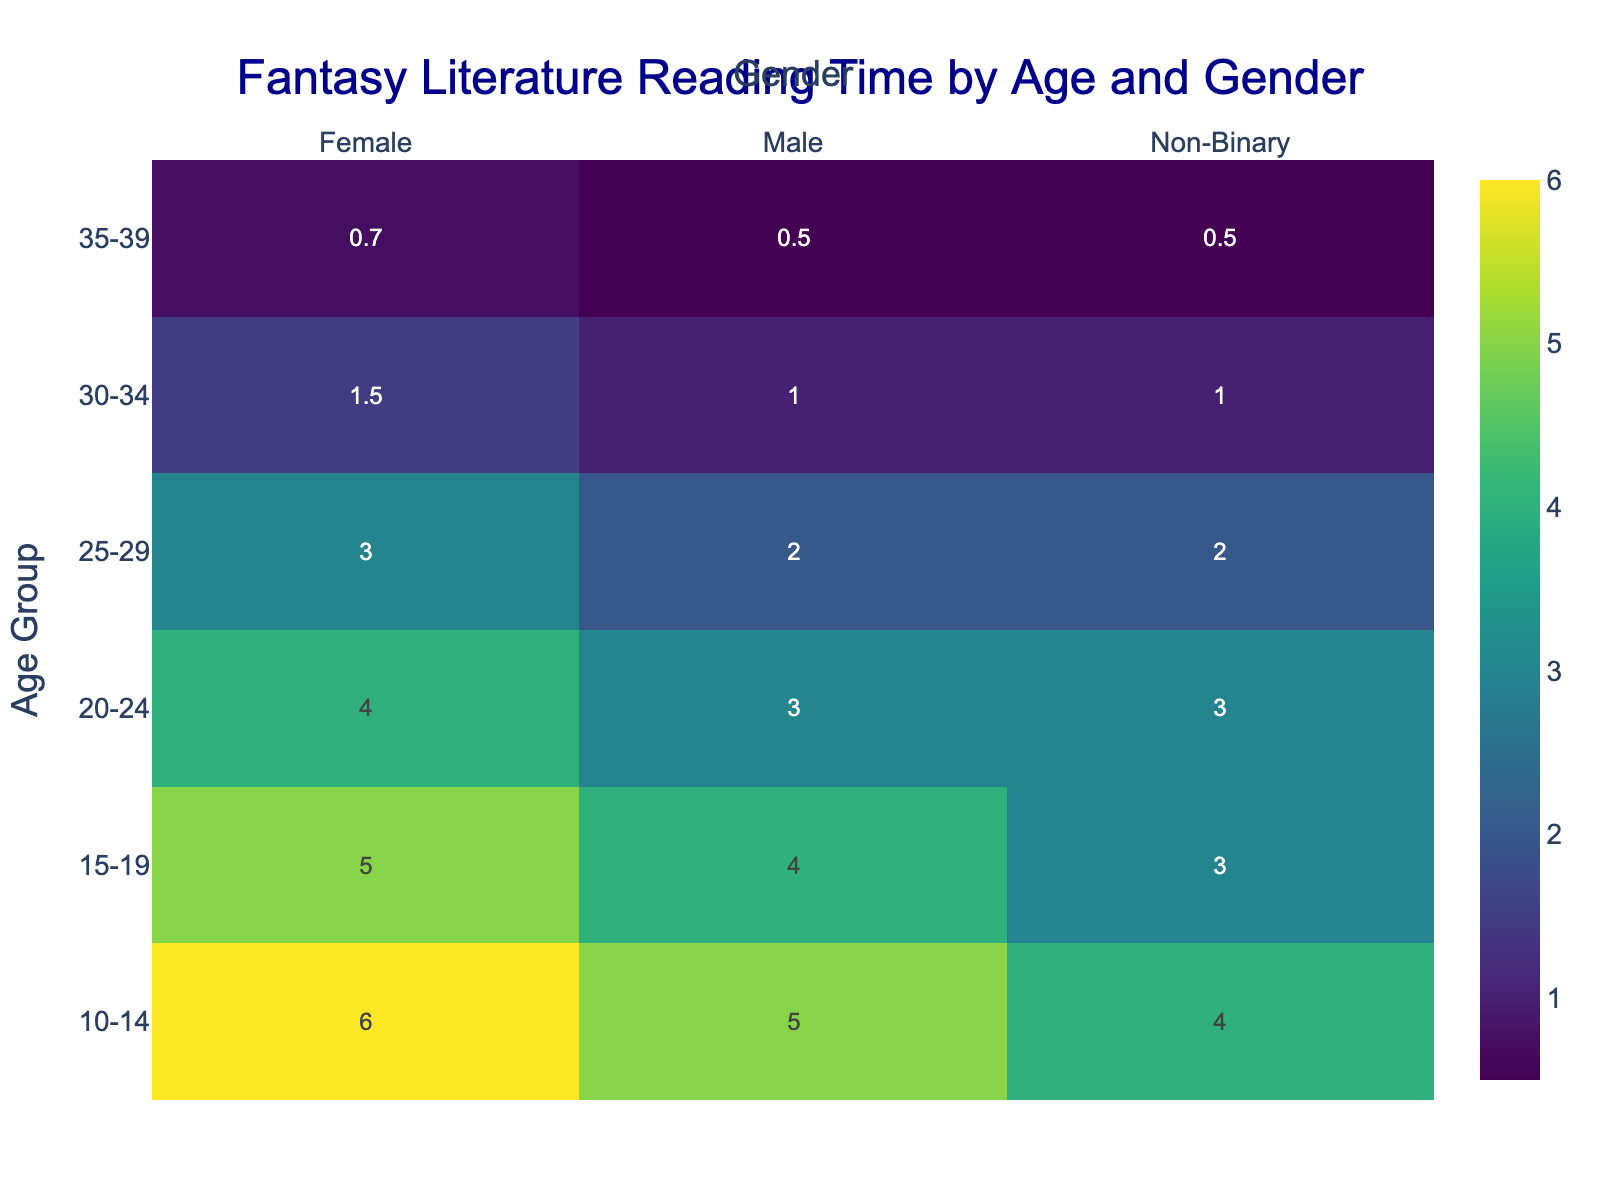What's the title of the heatmap? The title is displayed at the top center of the heatmap. It provides an overview of what the heatmap is about.
Answer: Fantasy Literature Reading Time by Age and Gender Which age group spends the most hours reading per week? To find this, look at the values in the heatmap and identify the maximum value. The age group with the highest value is the answer.
Answer: 10-14 How many hours per week do 25-29 Non-Binary individuals spend reading? Locate the intersection of the '25-29' age group and 'Non-Binary' gender column in the heatmap to find the value.
Answer: 2 Which gender in the 35-39 age group reads the least on average? Locate the values for each gender in the '35-39' age group and calculate the average for each gender. The gender with the lowest average is the answer.
Answer: Non-Binary What is the difference in reading time between 10-14 Females and 20-24 Males? Find the values for '10-14' Females and '20-24' Males in the heatmap and subtract the latter from the former.
Answer: 3 hours What is the average weekly reading time for the ‘20-24’ age group? Sum up the reading hours for all genders in the '20-24' age group and divide by the number of genders (3 in this case).
Answer: 3.33 hours Which gender in the '15-19' age group spends the most time reading? Locate the values for each gender in the '15-19' age group and identify the highest value. The corresponding gender is the answer.
Answer: Female Is there any age group where all genders spend exactly the same amount of time reading? Check each age group and compare the values for all genders. If any age group has the same value for all genders, that is the answer.
Answer: No What's the total reading time for Females in all age groups combined? Sum the values of hours per week for Females across all age groups.
Answer: 20.2 hours 